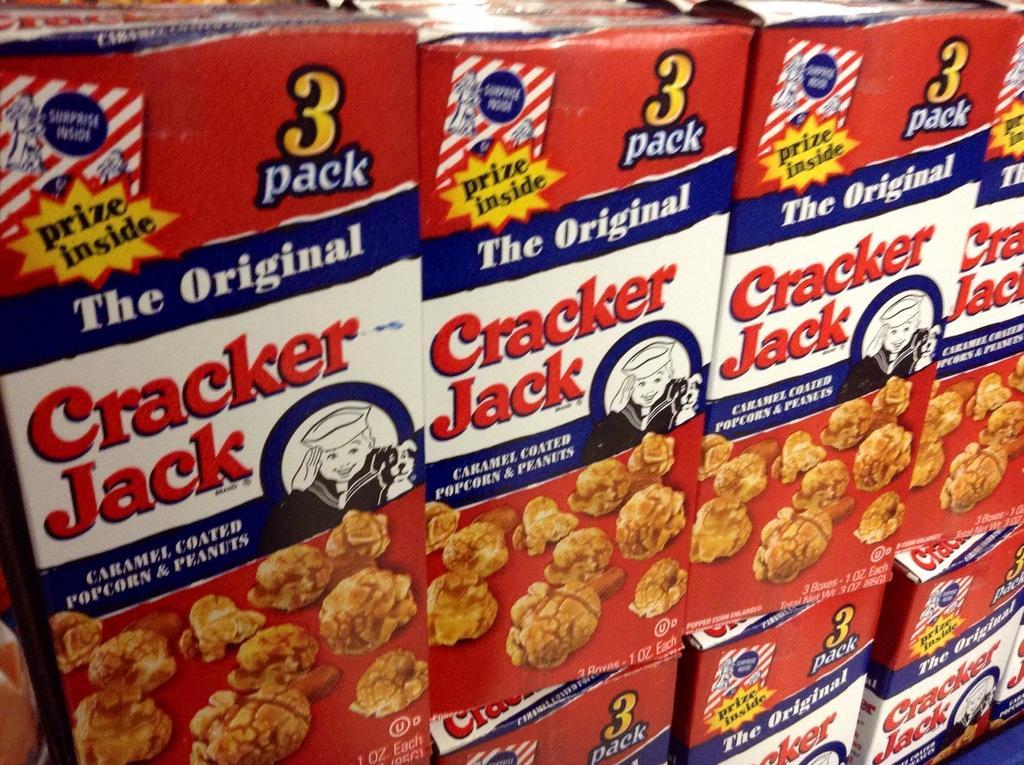How would you summarize this image in a sentence or two? In this image we can see many food boxes. On the boxes we can see the labels. On the labels we can see some text and images. 